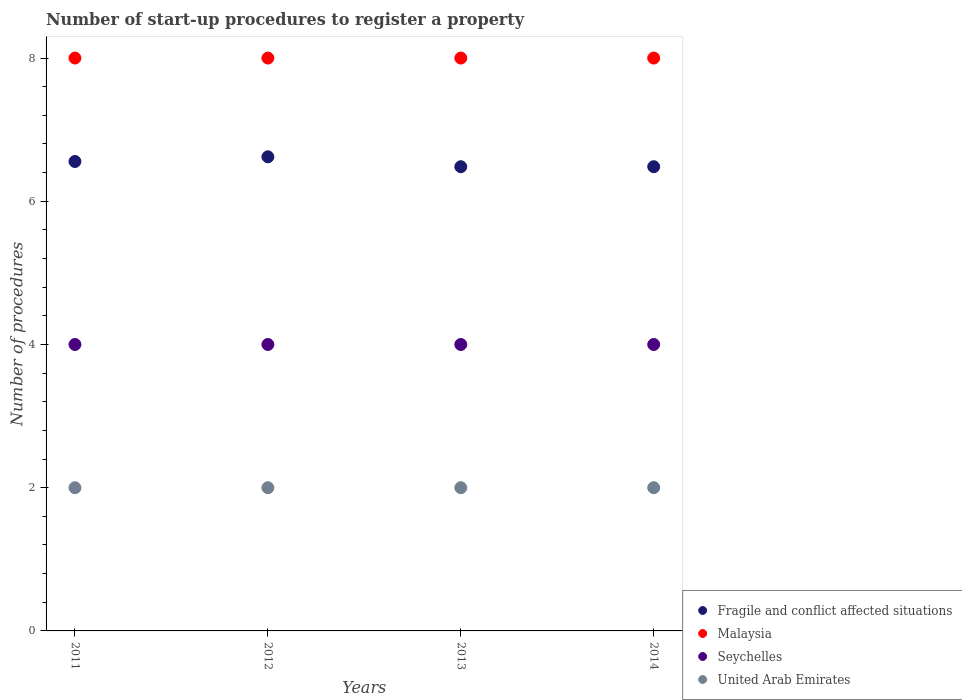What is the number of procedures required to register a property in Malaysia in 2014?
Ensure brevity in your answer.  8. Across all years, what is the maximum number of procedures required to register a property in United Arab Emirates?
Ensure brevity in your answer.  2. Across all years, what is the minimum number of procedures required to register a property in Malaysia?
Give a very brief answer. 8. In which year was the number of procedures required to register a property in Fragile and conflict affected situations maximum?
Offer a very short reply. 2012. What is the total number of procedures required to register a property in Malaysia in the graph?
Provide a short and direct response. 32. What is the difference between the number of procedures required to register a property in Malaysia in 2012 and that in 2014?
Your answer should be very brief. 0. What is the difference between the number of procedures required to register a property in Malaysia in 2014 and the number of procedures required to register a property in United Arab Emirates in 2012?
Give a very brief answer. 6. What is the average number of procedures required to register a property in Fragile and conflict affected situations per year?
Provide a short and direct response. 6.54. In the year 2011, what is the difference between the number of procedures required to register a property in Fragile and conflict affected situations and number of procedures required to register a property in Seychelles?
Your answer should be compact. 2.56. What is the ratio of the number of procedures required to register a property in Fragile and conflict affected situations in 2011 to that in 2013?
Ensure brevity in your answer.  1.01. Is the difference between the number of procedures required to register a property in Fragile and conflict affected situations in 2011 and 2012 greater than the difference between the number of procedures required to register a property in Seychelles in 2011 and 2012?
Your response must be concise. No. What is the difference between the highest and the lowest number of procedures required to register a property in Fragile and conflict affected situations?
Provide a succinct answer. 0.14. Is it the case that in every year, the sum of the number of procedures required to register a property in Fragile and conflict affected situations and number of procedures required to register a property in United Arab Emirates  is greater than the sum of number of procedures required to register a property in Malaysia and number of procedures required to register a property in Seychelles?
Provide a short and direct response. Yes. Is it the case that in every year, the sum of the number of procedures required to register a property in United Arab Emirates and number of procedures required to register a property in Seychelles  is greater than the number of procedures required to register a property in Malaysia?
Provide a succinct answer. No. Does the number of procedures required to register a property in United Arab Emirates monotonically increase over the years?
Provide a succinct answer. No. How many years are there in the graph?
Make the answer very short. 4. Does the graph contain any zero values?
Give a very brief answer. No. Does the graph contain grids?
Make the answer very short. No. Where does the legend appear in the graph?
Provide a succinct answer. Bottom right. How are the legend labels stacked?
Give a very brief answer. Vertical. What is the title of the graph?
Offer a very short reply. Number of start-up procedures to register a property. Does "Switzerland" appear as one of the legend labels in the graph?
Your answer should be very brief. No. What is the label or title of the X-axis?
Give a very brief answer. Years. What is the label or title of the Y-axis?
Your answer should be very brief. Number of procedures. What is the Number of procedures of Fragile and conflict affected situations in 2011?
Make the answer very short. 6.56. What is the Number of procedures of Seychelles in 2011?
Keep it short and to the point. 4. What is the Number of procedures in United Arab Emirates in 2011?
Give a very brief answer. 2. What is the Number of procedures in Fragile and conflict affected situations in 2012?
Give a very brief answer. 6.62. What is the Number of procedures in Fragile and conflict affected situations in 2013?
Offer a terse response. 6.48. What is the Number of procedures of Malaysia in 2013?
Your response must be concise. 8. What is the Number of procedures of United Arab Emirates in 2013?
Your answer should be very brief. 2. What is the Number of procedures of Fragile and conflict affected situations in 2014?
Provide a short and direct response. 6.48. What is the Number of procedures of Malaysia in 2014?
Provide a short and direct response. 8. What is the Number of procedures of Seychelles in 2014?
Keep it short and to the point. 4. What is the Number of procedures of United Arab Emirates in 2014?
Offer a very short reply. 2. Across all years, what is the maximum Number of procedures of Fragile and conflict affected situations?
Your answer should be very brief. 6.62. Across all years, what is the maximum Number of procedures in Seychelles?
Offer a very short reply. 4. Across all years, what is the minimum Number of procedures of Fragile and conflict affected situations?
Your answer should be very brief. 6.48. Across all years, what is the minimum Number of procedures in Seychelles?
Make the answer very short. 4. Across all years, what is the minimum Number of procedures in United Arab Emirates?
Your answer should be very brief. 2. What is the total Number of procedures of Fragile and conflict affected situations in the graph?
Keep it short and to the point. 26.14. What is the total Number of procedures of Malaysia in the graph?
Offer a terse response. 32. What is the total Number of procedures in United Arab Emirates in the graph?
Your response must be concise. 8. What is the difference between the Number of procedures in Fragile and conflict affected situations in 2011 and that in 2012?
Provide a short and direct response. -0.07. What is the difference between the Number of procedures of Malaysia in 2011 and that in 2012?
Ensure brevity in your answer.  0. What is the difference between the Number of procedures in Seychelles in 2011 and that in 2012?
Your answer should be very brief. 0. What is the difference between the Number of procedures of United Arab Emirates in 2011 and that in 2012?
Give a very brief answer. 0. What is the difference between the Number of procedures of Fragile and conflict affected situations in 2011 and that in 2013?
Ensure brevity in your answer.  0.07. What is the difference between the Number of procedures in Malaysia in 2011 and that in 2013?
Your answer should be compact. 0. What is the difference between the Number of procedures of Seychelles in 2011 and that in 2013?
Your answer should be compact. 0. What is the difference between the Number of procedures of United Arab Emirates in 2011 and that in 2013?
Provide a short and direct response. 0. What is the difference between the Number of procedures of Fragile and conflict affected situations in 2011 and that in 2014?
Offer a terse response. 0.07. What is the difference between the Number of procedures of Malaysia in 2011 and that in 2014?
Make the answer very short. 0. What is the difference between the Number of procedures of Seychelles in 2011 and that in 2014?
Make the answer very short. 0. What is the difference between the Number of procedures of Fragile and conflict affected situations in 2012 and that in 2013?
Keep it short and to the point. 0.14. What is the difference between the Number of procedures in United Arab Emirates in 2012 and that in 2013?
Give a very brief answer. 0. What is the difference between the Number of procedures of Fragile and conflict affected situations in 2012 and that in 2014?
Your answer should be compact. 0.14. What is the difference between the Number of procedures in Malaysia in 2012 and that in 2014?
Your answer should be compact. 0. What is the difference between the Number of procedures of Seychelles in 2012 and that in 2014?
Offer a very short reply. 0. What is the difference between the Number of procedures of Malaysia in 2013 and that in 2014?
Your answer should be very brief. 0. What is the difference between the Number of procedures of Fragile and conflict affected situations in 2011 and the Number of procedures of Malaysia in 2012?
Provide a short and direct response. -1.44. What is the difference between the Number of procedures in Fragile and conflict affected situations in 2011 and the Number of procedures in Seychelles in 2012?
Offer a terse response. 2.56. What is the difference between the Number of procedures of Fragile and conflict affected situations in 2011 and the Number of procedures of United Arab Emirates in 2012?
Provide a short and direct response. 4.56. What is the difference between the Number of procedures in Malaysia in 2011 and the Number of procedures in Seychelles in 2012?
Keep it short and to the point. 4. What is the difference between the Number of procedures in Malaysia in 2011 and the Number of procedures in United Arab Emirates in 2012?
Provide a succinct answer. 6. What is the difference between the Number of procedures of Seychelles in 2011 and the Number of procedures of United Arab Emirates in 2012?
Make the answer very short. 2. What is the difference between the Number of procedures of Fragile and conflict affected situations in 2011 and the Number of procedures of Malaysia in 2013?
Provide a succinct answer. -1.44. What is the difference between the Number of procedures in Fragile and conflict affected situations in 2011 and the Number of procedures in Seychelles in 2013?
Provide a short and direct response. 2.56. What is the difference between the Number of procedures in Fragile and conflict affected situations in 2011 and the Number of procedures in United Arab Emirates in 2013?
Your response must be concise. 4.56. What is the difference between the Number of procedures of Malaysia in 2011 and the Number of procedures of Seychelles in 2013?
Offer a terse response. 4. What is the difference between the Number of procedures in Malaysia in 2011 and the Number of procedures in United Arab Emirates in 2013?
Offer a terse response. 6. What is the difference between the Number of procedures of Seychelles in 2011 and the Number of procedures of United Arab Emirates in 2013?
Provide a succinct answer. 2. What is the difference between the Number of procedures of Fragile and conflict affected situations in 2011 and the Number of procedures of Malaysia in 2014?
Give a very brief answer. -1.44. What is the difference between the Number of procedures in Fragile and conflict affected situations in 2011 and the Number of procedures in Seychelles in 2014?
Offer a very short reply. 2.56. What is the difference between the Number of procedures in Fragile and conflict affected situations in 2011 and the Number of procedures in United Arab Emirates in 2014?
Offer a very short reply. 4.56. What is the difference between the Number of procedures in Malaysia in 2011 and the Number of procedures in Seychelles in 2014?
Give a very brief answer. 4. What is the difference between the Number of procedures of Malaysia in 2011 and the Number of procedures of United Arab Emirates in 2014?
Your answer should be very brief. 6. What is the difference between the Number of procedures in Seychelles in 2011 and the Number of procedures in United Arab Emirates in 2014?
Ensure brevity in your answer.  2. What is the difference between the Number of procedures in Fragile and conflict affected situations in 2012 and the Number of procedures in Malaysia in 2013?
Make the answer very short. -1.38. What is the difference between the Number of procedures of Fragile and conflict affected situations in 2012 and the Number of procedures of Seychelles in 2013?
Your answer should be compact. 2.62. What is the difference between the Number of procedures of Fragile and conflict affected situations in 2012 and the Number of procedures of United Arab Emirates in 2013?
Make the answer very short. 4.62. What is the difference between the Number of procedures in Malaysia in 2012 and the Number of procedures in United Arab Emirates in 2013?
Provide a short and direct response. 6. What is the difference between the Number of procedures of Fragile and conflict affected situations in 2012 and the Number of procedures of Malaysia in 2014?
Provide a succinct answer. -1.38. What is the difference between the Number of procedures of Fragile and conflict affected situations in 2012 and the Number of procedures of Seychelles in 2014?
Offer a terse response. 2.62. What is the difference between the Number of procedures of Fragile and conflict affected situations in 2012 and the Number of procedures of United Arab Emirates in 2014?
Give a very brief answer. 4.62. What is the difference between the Number of procedures of Malaysia in 2012 and the Number of procedures of Seychelles in 2014?
Provide a succinct answer. 4. What is the difference between the Number of procedures in Malaysia in 2012 and the Number of procedures in United Arab Emirates in 2014?
Provide a short and direct response. 6. What is the difference between the Number of procedures in Fragile and conflict affected situations in 2013 and the Number of procedures in Malaysia in 2014?
Give a very brief answer. -1.52. What is the difference between the Number of procedures of Fragile and conflict affected situations in 2013 and the Number of procedures of Seychelles in 2014?
Ensure brevity in your answer.  2.48. What is the difference between the Number of procedures in Fragile and conflict affected situations in 2013 and the Number of procedures in United Arab Emirates in 2014?
Offer a very short reply. 4.48. What is the difference between the Number of procedures in Malaysia in 2013 and the Number of procedures in Seychelles in 2014?
Keep it short and to the point. 4. What is the difference between the Number of procedures in Malaysia in 2013 and the Number of procedures in United Arab Emirates in 2014?
Keep it short and to the point. 6. What is the average Number of procedures in Fragile and conflict affected situations per year?
Keep it short and to the point. 6.54. What is the average Number of procedures of Malaysia per year?
Provide a short and direct response. 8. In the year 2011, what is the difference between the Number of procedures in Fragile and conflict affected situations and Number of procedures in Malaysia?
Provide a short and direct response. -1.44. In the year 2011, what is the difference between the Number of procedures in Fragile and conflict affected situations and Number of procedures in Seychelles?
Give a very brief answer. 2.56. In the year 2011, what is the difference between the Number of procedures of Fragile and conflict affected situations and Number of procedures of United Arab Emirates?
Your response must be concise. 4.56. In the year 2011, what is the difference between the Number of procedures of Malaysia and Number of procedures of Seychelles?
Offer a very short reply. 4. In the year 2011, what is the difference between the Number of procedures of Malaysia and Number of procedures of United Arab Emirates?
Provide a succinct answer. 6. In the year 2011, what is the difference between the Number of procedures in Seychelles and Number of procedures in United Arab Emirates?
Keep it short and to the point. 2. In the year 2012, what is the difference between the Number of procedures in Fragile and conflict affected situations and Number of procedures in Malaysia?
Offer a terse response. -1.38. In the year 2012, what is the difference between the Number of procedures in Fragile and conflict affected situations and Number of procedures in Seychelles?
Provide a short and direct response. 2.62. In the year 2012, what is the difference between the Number of procedures in Fragile and conflict affected situations and Number of procedures in United Arab Emirates?
Keep it short and to the point. 4.62. In the year 2012, what is the difference between the Number of procedures of Seychelles and Number of procedures of United Arab Emirates?
Ensure brevity in your answer.  2. In the year 2013, what is the difference between the Number of procedures in Fragile and conflict affected situations and Number of procedures in Malaysia?
Your response must be concise. -1.52. In the year 2013, what is the difference between the Number of procedures in Fragile and conflict affected situations and Number of procedures in Seychelles?
Offer a very short reply. 2.48. In the year 2013, what is the difference between the Number of procedures of Fragile and conflict affected situations and Number of procedures of United Arab Emirates?
Keep it short and to the point. 4.48. In the year 2014, what is the difference between the Number of procedures of Fragile and conflict affected situations and Number of procedures of Malaysia?
Provide a short and direct response. -1.52. In the year 2014, what is the difference between the Number of procedures of Fragile and conflict affected situations and Number of procedures of Seychelles?
Ensure brevity in your answer.  2.48. In the year 2014, what is the difference between the Number of procedures in Fragile and conflict affected situations and Number of procedures in United Arab Emirates?
Ensure brevity in your answer.  4.48. In the year 2014, what is the difference between the Number of procedures of Malaysia and Number of procedures of Seychelles?
Make the answer very short. 4. In the year 2014, what is the difference between the Number of procedures of Malaysia and Number of procedures of United Arab Emirates?
Your answer should be compact. 6. What is the ratio of the Number of procedures of Fragile and conflict affected situations in 2011 to that in 2012?
Give a very brief answer. 0.99. What is the ratio of the Number of procedures of Fragile and conflict affected situations in 2011 to that in 2013?
Make the answer very short. 1.01. What is the ratio of the Number of procedures in United Arab Emirates in 2011 to that in 2013?
Provide a short and direct response. 1. What is the ratio of the Number of procedures in Fragile and conflict affected situations in 2011 to that in 2014?
Provide a succinct answer. 1.01. What is the ratio of the Number of procedures in Malaysia in 2011 to that in 2014?
Make the answer very short. 1. What is the ratio of the Number of procedures of Seychelles in 2011 to that in 2014?
Offer a very short reply. 1. What is the ratio of the Number of procedures of Fragile and conflict affected situations in 2012 to that in 2013?
Make the answer very short. 1.02. What is the ratio of the Number of procedures in Seychelles in 2012 to that in 2013?
Provide a short and direct response. 1. What is the ratio of the Number of procedures of Fragile and conflict affected situations in 2012 to that in 2014?
Keep it short and to the point. 1.02. What is the ratio of the Number of procedures in Seychelles in 2013 to that in 2014?
Offer a terse response. 1. What is the ratio of the Number of procedures of United Arab Emirates in 2013 to that in 2014?
Make the answer very short. 1. What is the difference between the highest and the second highest Number of procedures of Fragile and conflict affected situations?
Your answer should be compact. 0.07. What is the difference between the highest and the lowest Number of procedures of Fragile and conflict affected situations?
Provide a succinct answer. 0.14. 